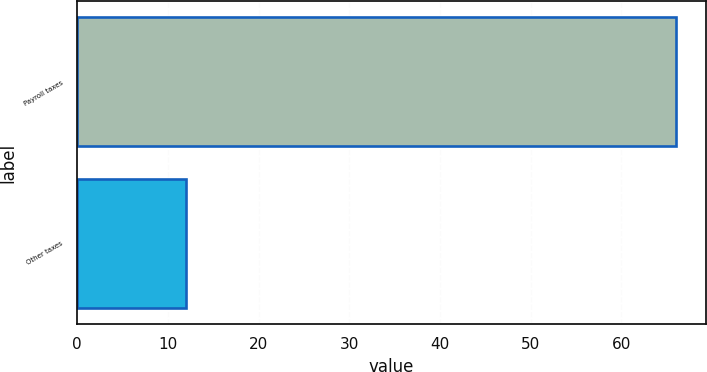Convert chart. <chart><loc_0><loc_0><loc_500><loc_500><bar_chart><fcel>Payroll taxes<fcel>Other taxes<nl><fcel>66<fcel>12<nl></chart> 